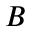<formula> <loc_0><loc_0><loc_500><loc_500>B</formula> 